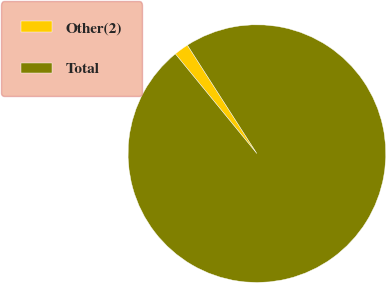Convert chart. <chart><loc_0><loc_0><loc_500><loc_500><pie_chart><fcel>Other(2)<fcel>Total<nl><fcel>1.84%<fcel>98.16%<nl></chart> 